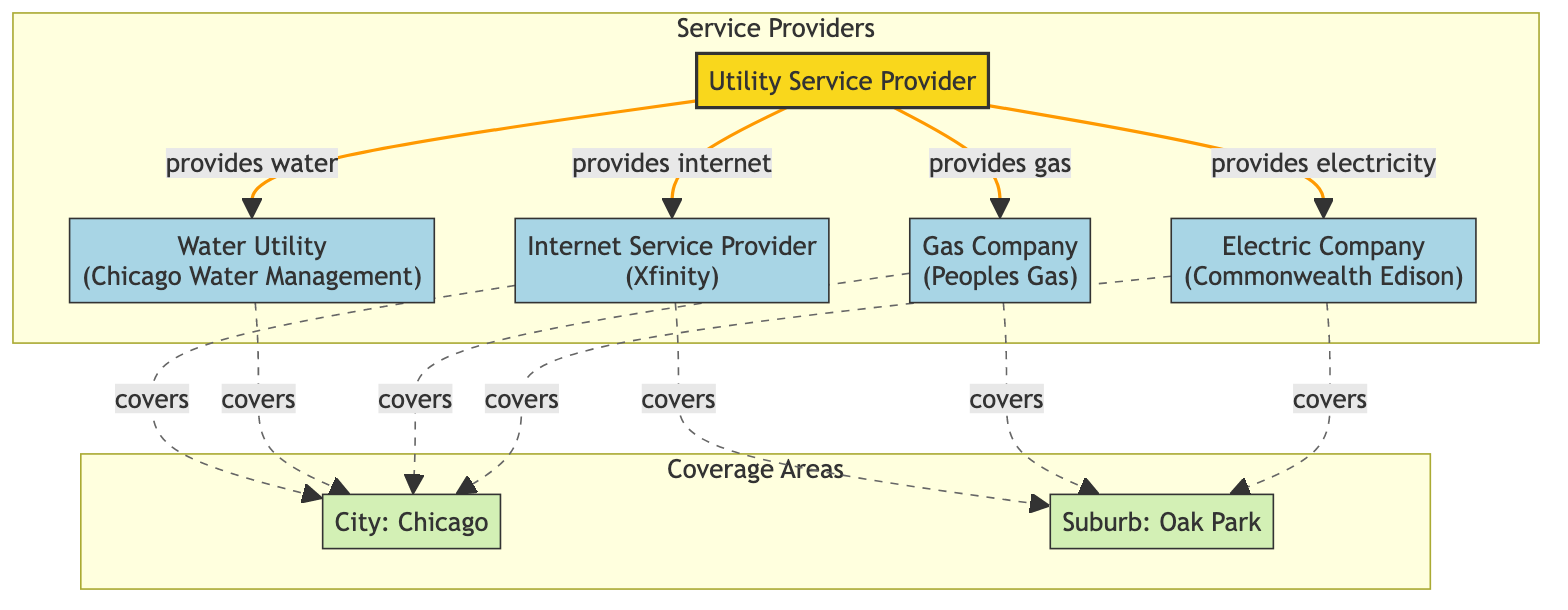What utility company provides electricity? Looking at the nodes related to the service providers, the node labeled "Electric Company" corresponds to "Commonwealth Edison", which is the utility company that provides electricity.
Answer: Commonwealth Edison How many coverage areas are shown in the diagram? The diagram has two coverage areas: "City: Chicago" and "Suburb: Oak Park," indicating that there are a total of two coverage areas represented.
Answer: 2 Which service provider is responsible for water? The "Water Utility" node explicitly lists "Chicago Water Management" as the service provider responsible for water in the area.
Answer: Chicago Water Management What is the relationship between the Utility Service Provider and the Internet Service Provider? The arrows indicate that the "Utility Service Provider" provides internet, and the specific Internet Service Provider in this case is "Xfinity." Thus, the relationship is that of provision.
Answer: provides internet Which areas does the Electric Company cover? The Electric Company (Commonwealth Edison) is connected to both coverage areas: "City: Chicago" and "Suburb: Oak Park," meaning that it serves both locations.
Answer: Chicago and Oak Park Which companies provide services in Chicago? The diagram indicates that "Commonwealth Edison," "Peoples Gas," "Chicago Water Management," and "Xfinity" all have a coverage area with "City: Chicago," meaning they provide services there.
Answer: Commonwealth Edison, Peoples Gas, Chicago Water Management, Xfinity What is the main node of the diagram? The central node labeled "Utility Service Provider" represents the main focus of the diagram, connecting to various sub-nodes representing different service providers.
Answer: Utility Service Provider How many edges are connected to the Gas Company? The Gas Company (Peoples Gas) is linked to the Utility Service Provider, which means there is one edge connected between these two nodes in the network diagram.
Answer: 1 Which utility service provider only serves the City of Chicago? The diagram indicates that "Chicago Water Management" is the only utility service provider that is exclusively connected to the coverage area "City: Chicago," without a connection to "Suburb: Oak Park."
Answer: Chicago Water Management 